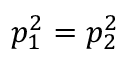Convert formula to latex. <formula><loc_0><loc_0><loc_500><loc_500>p _ { 1 } ^ { 2 } = p _ { 2 } ^ { 2 }</formula> 